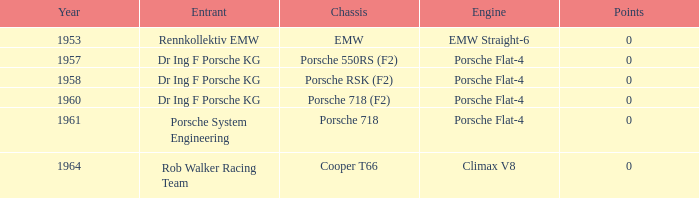What chassis did the porsche flat-4 use before 1958? Porsche 550RS (F2). 